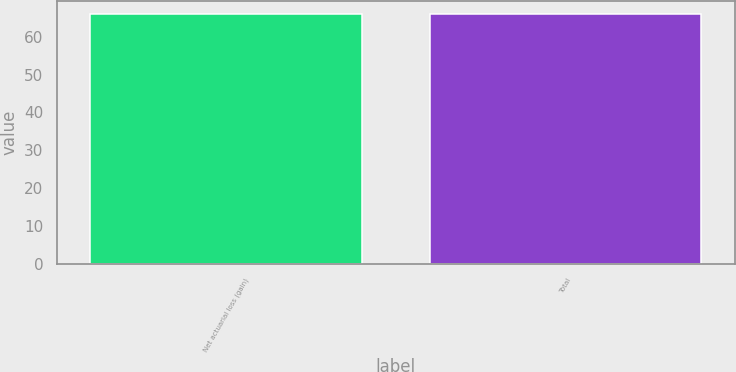Convert chart. <chart><loc_0><loc_0><loc_500><loc_500><bar_chart><fcel>Net actuarial loss (gain)<fcel>Total<nl><fcel>66<fcel>66.1<nl></chart> 